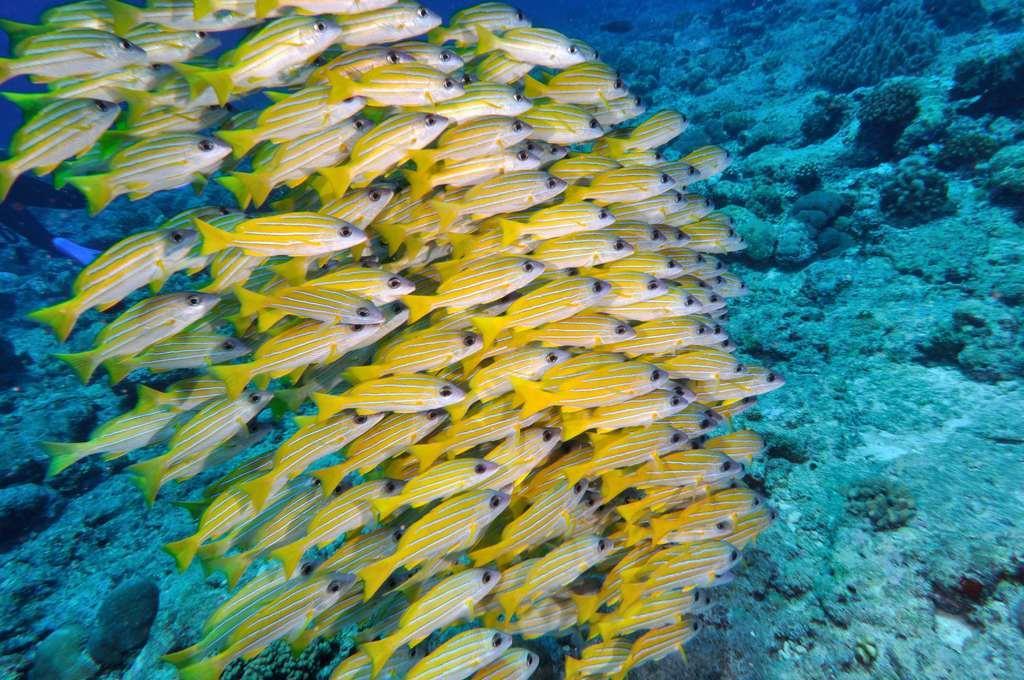In one or two sentences, can you explain what this image depicts? Here, we can some fishes which are in yellow color and there is water. 